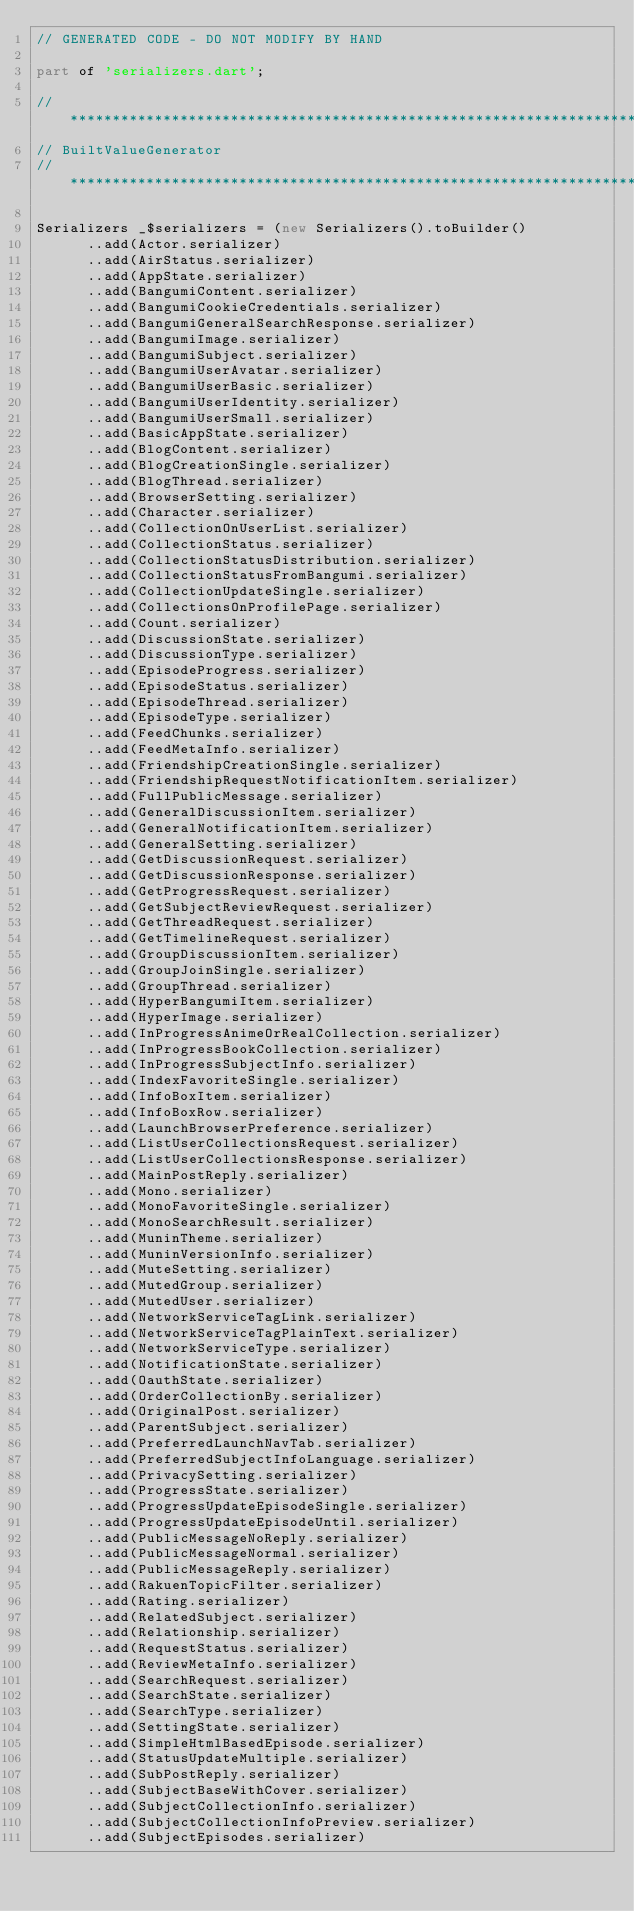<code> <loc_0><loc_0><loc_500><loc_500><_Dart_>// GENERATED CODE - DO NOT MODIFY BY HAND

part of 'serializers.dart';

// **************************************************************************
// BuiltValueGenerator
// **************************************************************************

Serializers _$serializers = (new Serializers().toBuilder()
      ..add(Actor.serializer)
      ..add(AirStatus.serializer)
      ..add(AppState.serializer)
      ..add(BangumiContent.serializer)
      ..add(BangumiCookieCredentials.serializer)
      ..add(BangumiGeneralSearchResponse.serializer)
      ..add(BangumiImage.serializer)
      ..add(BangumiSubject.serializer)
      ..add(BangumiUserAvatar.serializer)
      ..add(BangumiUserBasic.serializer)
      ..add(BangumiUserIdentity.serializer)
      ..add(BangumiUserSmall.serializer)
      ..add(BasicAppState.serializer)
      ..add(BlogContent.serializer)
      ..add(BlogCreationSingle.serializer)
      ..add(BlogThread.serializer)
      ..add(BrowserSetting.serializer)
      ..add(Character.serializer)
      ..add(CollectionOnUserList.serializer)
      ..add(CollectionStatus.serializer)
      ..add(CollectionStatusDistribution.serializer)
      ..add(CollectionStatusFromBangumi.serializer)
      ..add(CollectionUpdateSingle.serializer)
      ..add(CollectionsOnProfilePage.serializer)
      ..add(Count.serializer)
      ..add(DiscussionState.serializer)
      ..add(DiscussionType.serializer)
      ..add(EpisodeProgress.serializer)
      ..add(EpisodeStatus.serializer)
      ..add(EpisodeThread.serializer)
      ..add(EpisodeType.serializer)
      ..add(FeedChunks.serializer)
      ..add(FeedMetaInfo.serializer)
      ..add(FriendshipCreationSingle.serializer)
      ..add(FriendshipRequestNotificationItem.serializer)
      ..add(FullPublicMessage.serializer)
      ..add(GeneralDiscussionItem.serializer)
      ..add(GeneralNotificationItem.serializer)
      ..add(GeneralSetting.serializer)
      ..add(GetDiscussionRequest.serializer)
      ..add(GetDiscussionResponse.serializer)
      ..add(GetProgressRequest.serializer)
      ..add(GetSubjectReviewRequest.serializer)
      ..add(GetThreadRequest.serializer)
      ..add(GetTimelineRequest.serializer)
      ..add(GroupDiscussionItem.serializer)
      ..add(GroupJoinSingle.serializer)
      ..add(GroupThread.serializer)
      ..add(HyperBangumiItem.serializer)
      ..add(HyperImage.serializer)
      ..add(InProgressAnimeOrRealCollection.serializer)
      ..add(InProgressBookCollection.serializer)
      ..add(InProgressSubjectInfo.serializer)
      ..add(IndexFavoriteSingle.serializer)
      ..add(InfoBoxItem.serializer)
      ..add(InfoBoxRow.serializer)
      ..add(LaunchBrowserPreference.serializer)
      ..add(ListUserCollectionsRequest.serializer)
      ..add(ListUserCollectionsResponse.serializer)
      ..add(MainPostReply.serializer)
      ..add(Mono.serializer)
      ..add(MonoFavoriteSingle.serializer)
      ..add(MonoSearchResult.serializer)
      ..add(MuninTheme.serializer)
      ..add(MuninVersionInfo.serializer)
      ..add(MuteSetting.serializer)
      ..add(MutedGroup.serializer)
      ..add(MutedUser.serializer)
      ..add(NetworkServiceTagLink.serializer)
      ..add(NetworkServiceTagPlainText.serializer)
      ..add(NetworkServiceType.serializer)
      ..add(NotificationState.serializer)
      ..add(OauthState.serializer)
      ..add(OrderCollectionBy.serializer)
      ..add(OriginalPost.serializer)
      ..add(ParentSubject.serializer)
      ..add(PreferredLaunchNavTab.serializer)
      ..add(PreferredSubjectInfoLanguage.serializer)
      ..add(PrivacySetting.serializer)
      ..add(ProgressState.serializer)
      ..add(ProgressUpdateEpisodeSingle.serializer)
      ..add(ProgressUpdateEpisodeUntil.serializer)
      ..add(PublicMessageNoReply.serializer)
      ..add(PublicMessageNormal.serializer)
      ..add(PublicMessageReply.serializer)
      ..add(RakuenTopicFilter.serializer)
      ..add(Rating.serializer)
      ..add(RelatedSubject.serializer)
      ..add(Relationship.serializer)
      ..add(RequestStatus.serializer)
      ..add(ReviewMetaInfo.serializer)
      ..add(SearchRequest.serializer)
      ..add(SearchState.serializer)
      ..add(SearchType.serializer)
      ..add(SettingState.serializer)
      ..add(SimpleHtmlBasedEpisode.serializer)
      ..add(StatusUpdateMultiple.serializer)
      ..add(SubPostReply.serializer)
      ..add(SubjectBaseWithCover.serializer)
      ..add(SubjectCollectionInfo.serializer)
      ..add(SubjectCollectionInfoPreview.serializer)
      ..add(SubjectEpisodes.serializer)</code> 